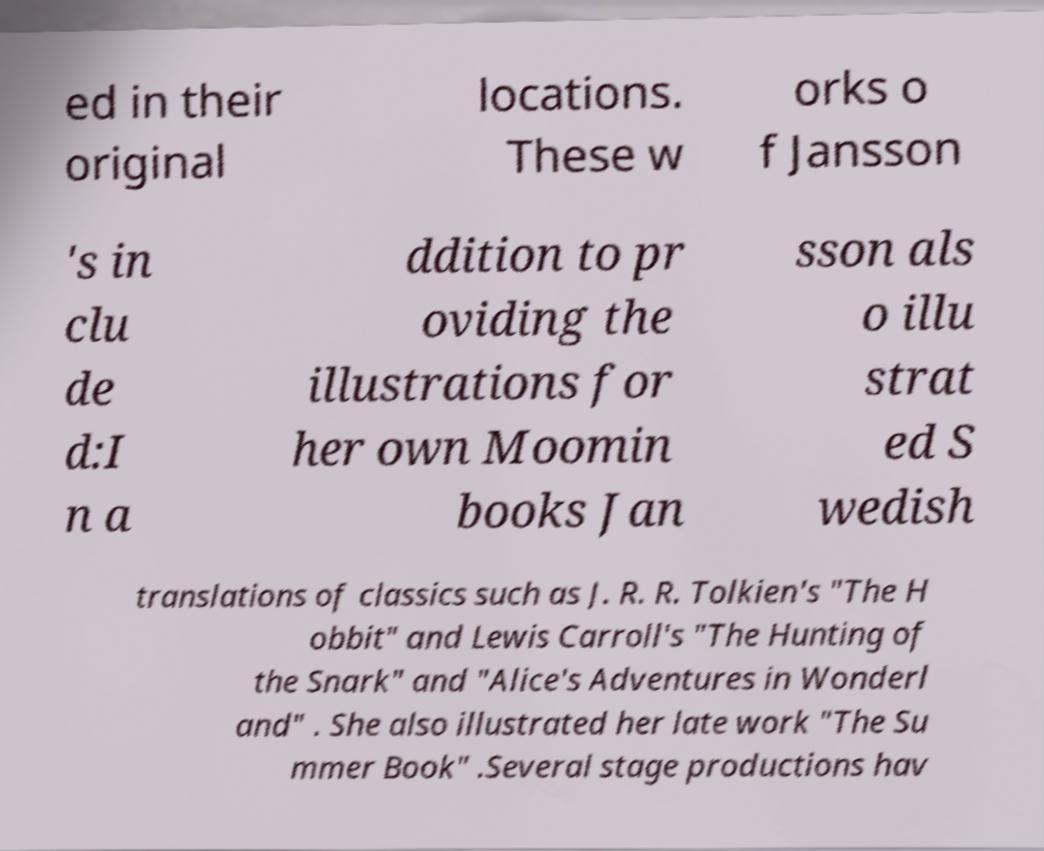Please read and relay the text visible in this image. What does it say? ed in their original locations. These w orks o f Jansson 's in clu de d:I n a ddition to pr oviding the illustrations for her own Moomin books Jan sson als o illu strat ed S wedish translations of classics such as J. R. R. Tolkien's "The H obbit" and Lewis Carroll's "The Hunting of the Snark" and "Alice's Adventures in Wonderl and" . She also illustrated her late work "The Su mmer Book" .Several stage productions hav 